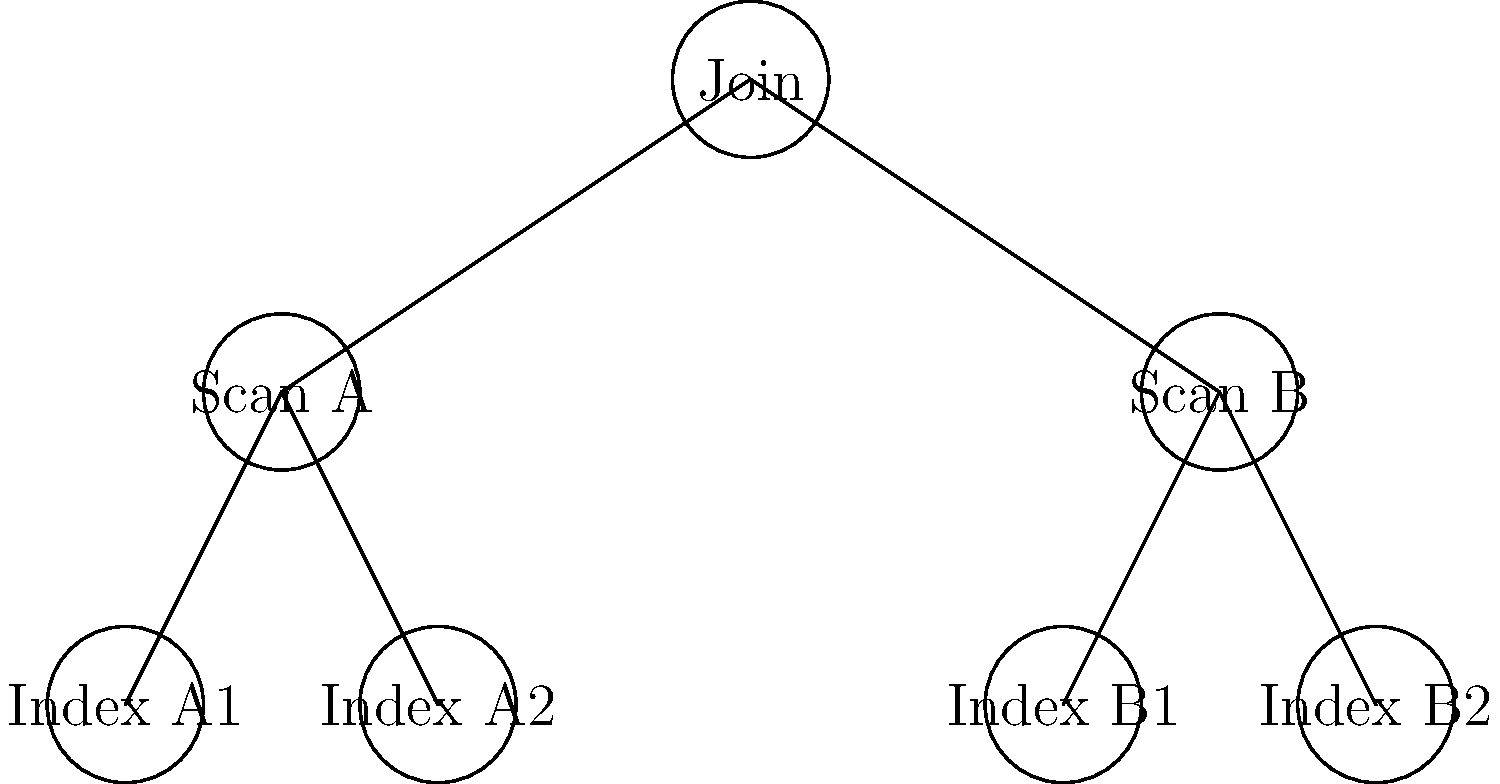In the given query execution plan tree, which operation is likely to be the most expensive in terms of computational resources, and why? To determine the most expensive operation in the query execution plan tree, we need to analyze the structure and operations:

1. The tree represents a join operation at the root, combining results from two table scans (Scan A and Scan B).

2. Each table scan is supported by two index operations (Index A1, Index A2 for Scan A; Index B1, Index B2 for Scan B).

3. Join operations are typically more expensive than scans or index lookups because they need to combine data from multiple sources.

4. The join operation is at the top of the tree, which means it processes the results of all other operations.

5. Join algorithms (e.g., nested loop join, hash join, merge join) often require significant memory and CPU resources to match rows from different tables.

6. The cost of the join increases with the size of the input data sets, which in this case are the results of two full table scans.

7. Table scans can be expensive for large tables, but they are generally less complex than joins in terms of computational requirements.

8. Index operations are usually faster than full table scans but less resource-intensive than joins.

Given these factors, the join operation at the root of the tree is likely to be the most expensive in terms of computational resources. It needs to process all the data from both table scans and perform the matching logic, which is typically more complex and resource-intensive than the other operations shown in the tree.
Answer: Join operation 